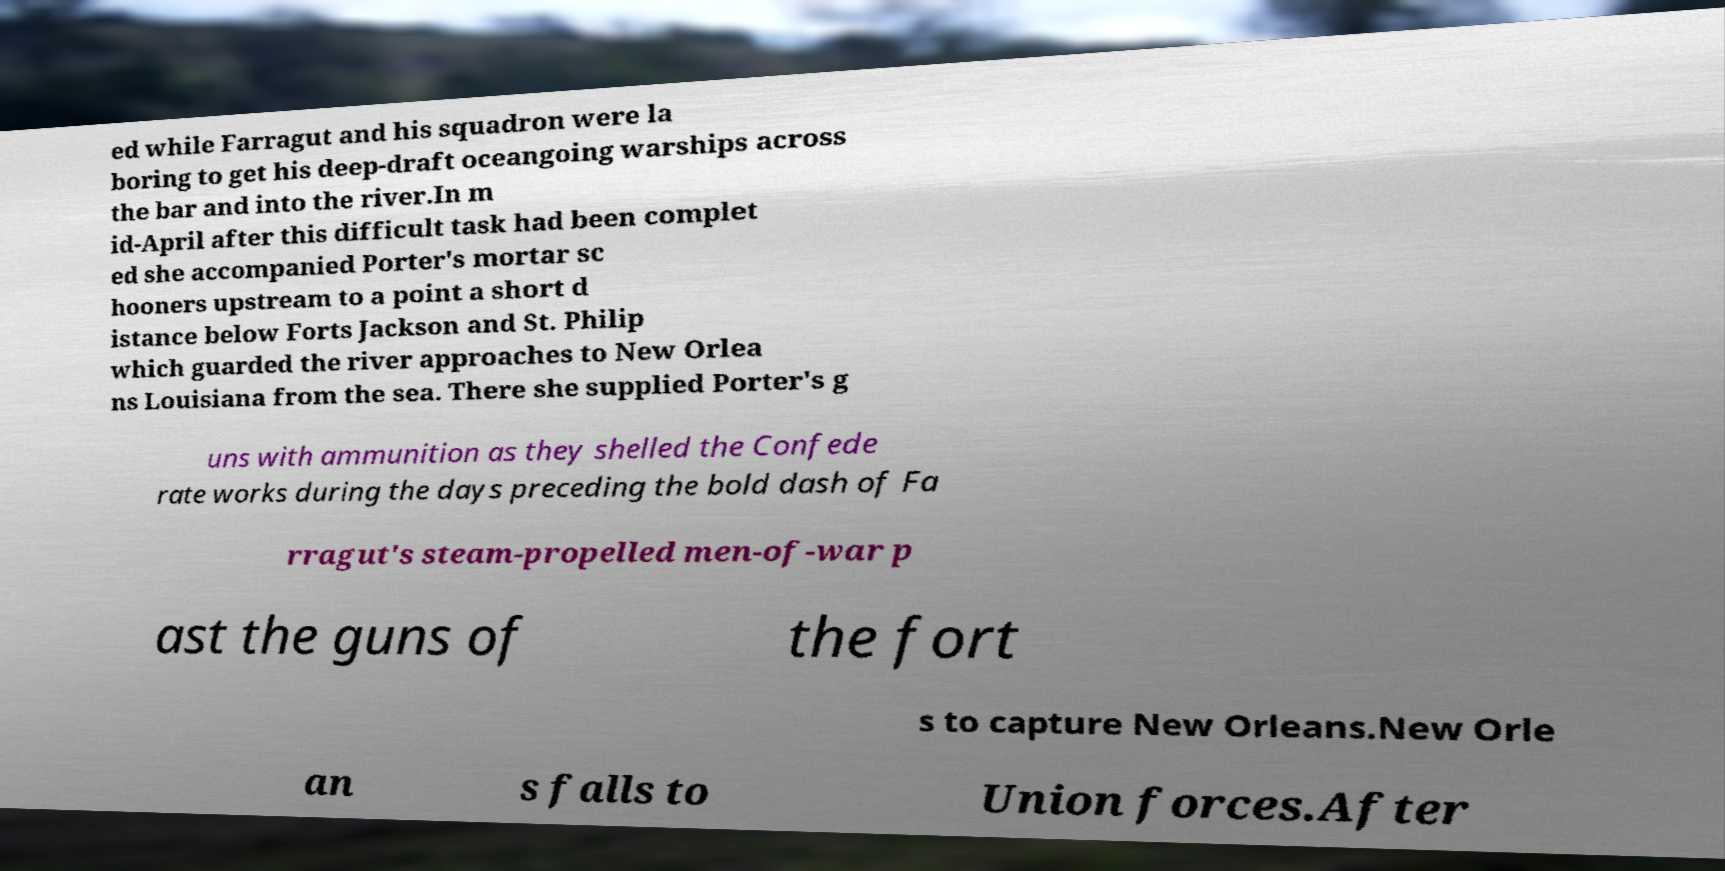For documentation purposes, I need the text within this image transcribed. Could you provide that? ed while Farragut and his squadron were la boring to get his deep-draft oceangoing warships across the bar and into the river.In m id-April after this difficult task had been complet ed she accompanied Porter's mortar sc hooners upstream to a point a short d istance below Forts Jackson and St. Philip which guarded the river approaches to New Orlea ns Louisiana from the sea. There she supplied Porter's g uns with ammunition as they shelled the Confede rate works during the days preceding the bold dash of Fa rragut's steam-propelled men-of-war p ast the guns of the fort s to capture New Orleans.New Orle an s falls to Union forces.After 